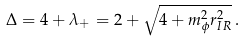Convert formula to latex. <formula><loc_0><loc_0><loc_500><loc_500>\Delta = 4 + \lambda _ { + } = 2 + \sqrt { 4 + m _ { \phi } ^ { 2 } r _ { I R } ^ { 2 } } \, .</formula> 